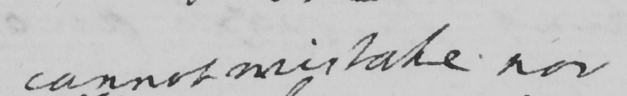What text is written in this handwritten line? cannot mistake nor 